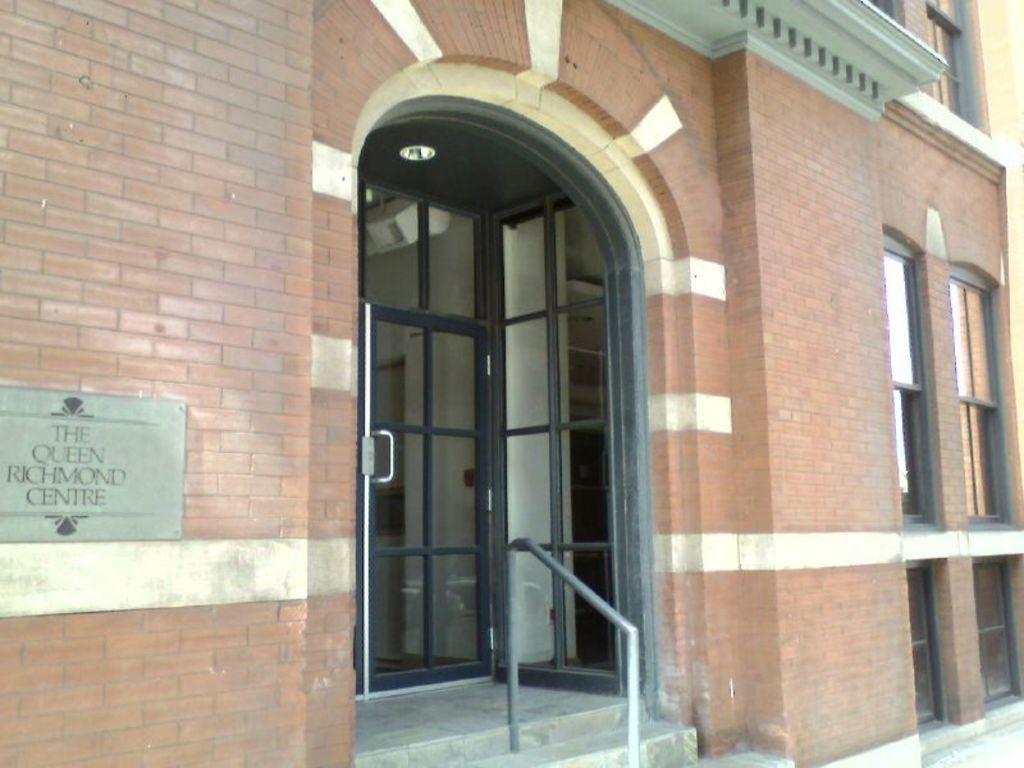Can you describe this image briefly? In this image there is a building with glass doors and windows, in front of the building there are stairs with a metal rod, on the building there is name engraved. 